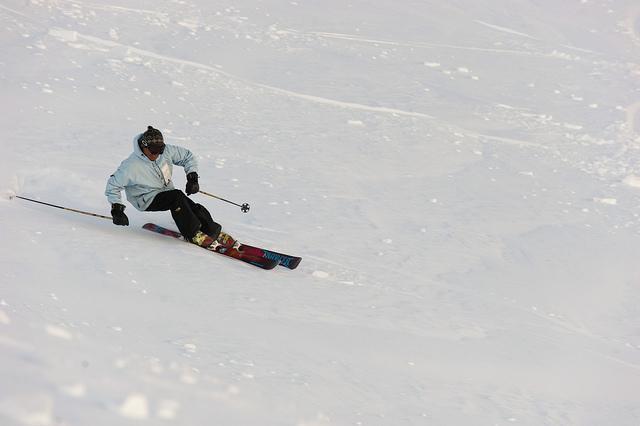How many cups on the table are wine glasses?
Give a very brief answer. 0. 